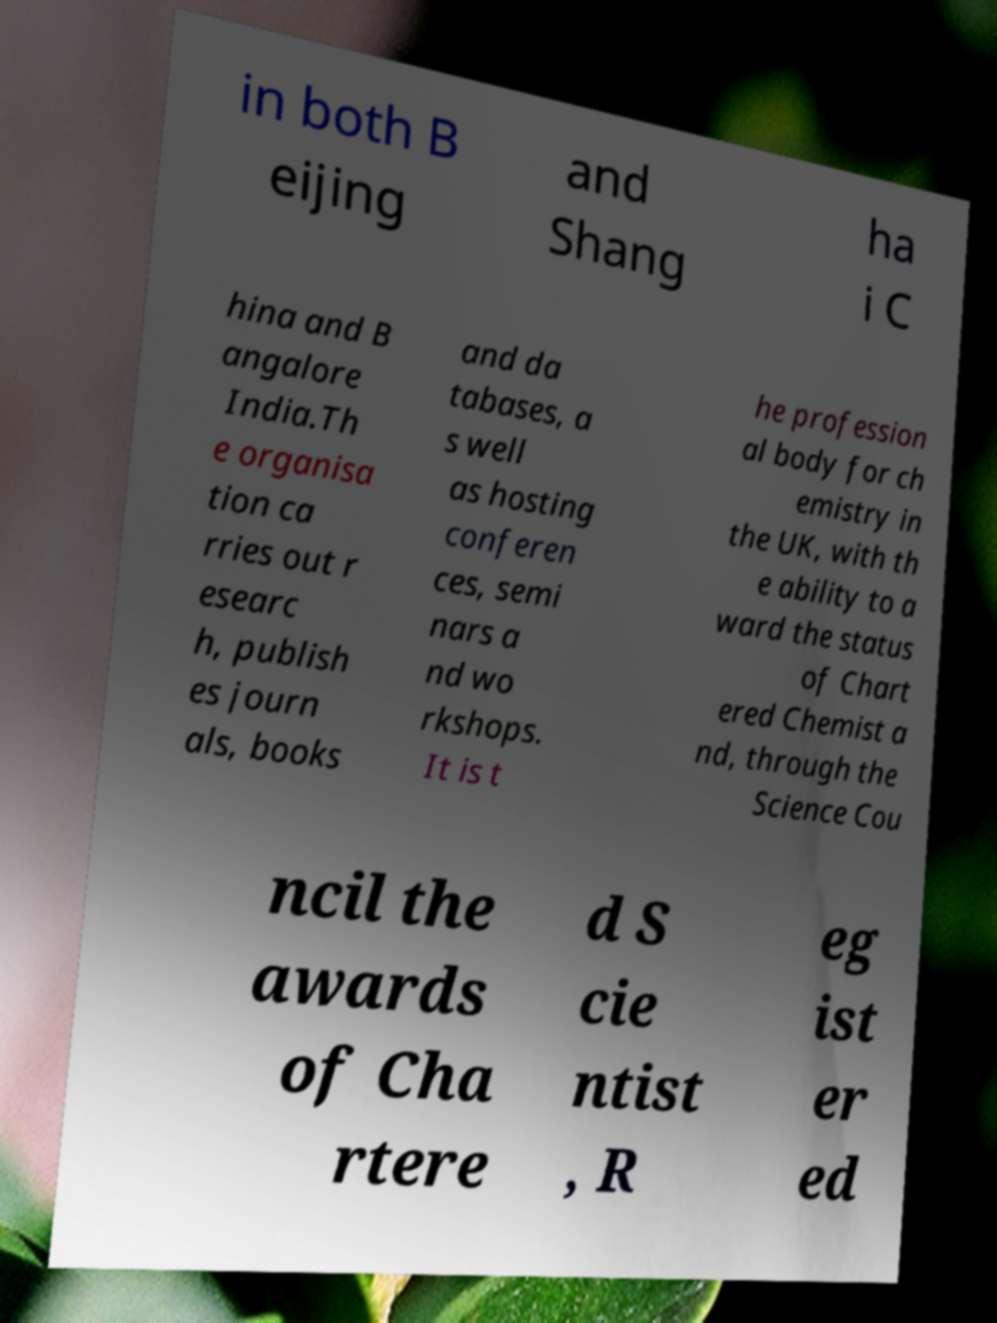What messages or text are displayed in this image? I need them in a readable, typed format. in both B eijing and Shang ha i C hina and B angalore India.Th e organisa tion ca rries out r esearc h, publish es journ als, books and da tabases, a s well as hosting conferen ces, semi nars a nd wo rkshops. It is t he profession al body for ch emistry in the UK, with th e ability to a ward the status of Chart ered Chemist a nd, through the Science Cou ncil the awards of Cha rtere d S cie ntist , R eg ist er ed 